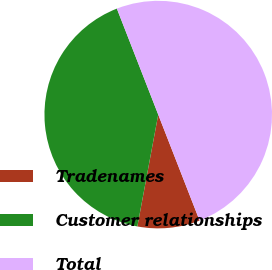Convert chart to OTSL. <chart><loc_0><loc_0><loc_500><loc_500><pie_chart><fcel>Tradenames<fcel>Customer relationships<fcel>Total<nl><fcel>8.86%<fcel>41.14%<fcel>50.0%<nl></chart> 